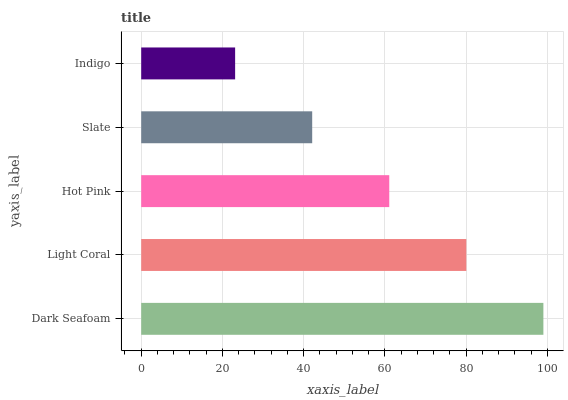Is Indigo the minimum?
Answer yes or no. Yes. Is Dark Seafoam the maximum?
Answer yes or no. Yes. Is Light Coral the minimum?
Answer yes or no. No. Is Light Coral the maximum?
Answer yes or no. No. Is Dark Seafoam greater than Light Coral?
Answer yes or no. Yes. Is Light Coral less than Dark Seafoam?
Answer yes or no. Yes. Is Light Coral greater than Dark Seafoam?
Answer yes or no. No. Is Dark Seafoam less than Light Coral?
Answer yes or no. No. Is Hot Pink the high median?
Answer yes or no. Yes. Is Hot Pink the low median?
Answer yes or no. Yes. Is Indigo the high median?
Answer yes or no. No. Is Light Coral the low median?
Answer yes or no. No. 